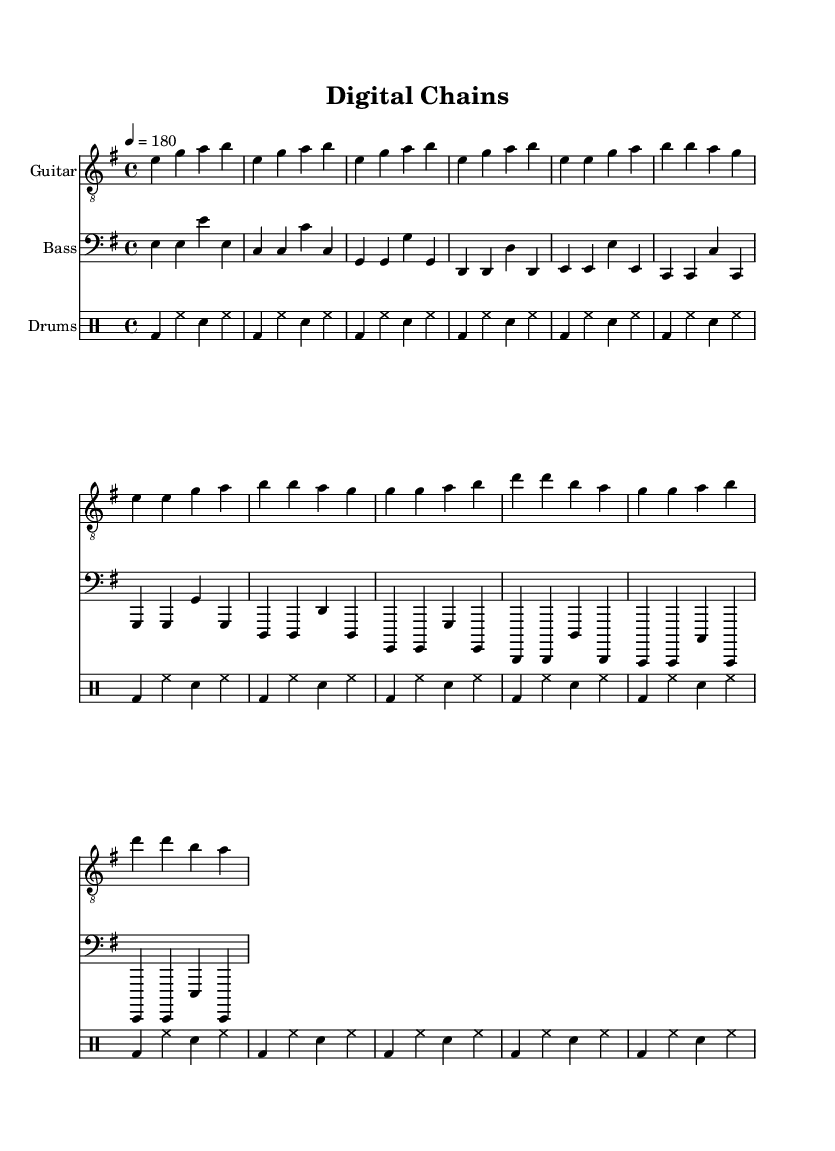What is the key signature of this music? The key signature is indicated by the sharp notes found at the beginning of the piece. In this case, it shows one sharp, which indicates it's in E minor.
Answer: E minor What is the time signature of this piece? The time signature is shown at the beginning of the sheet music, represented as a fraction. Here, it states 4 over 4, indicating four beats in a measure and a quarter note receives one beat.
Answer: 4/4 What is the tempo marking for this music? The tempo marking is indicated at the start with a number and a term. In this case, it shows 4 equals 180, meaning there are 180 beats per minute, reflecting a fast-paced tempo.
Answer: 180 How many measures are in the chorus section? By counting the segments of music notation within the chorus section, we can see there are four distinct measures. Each group of notes separated by vertical lines indicates one measure.
Answer: 4 What lyrical theme does this anthem address? The lyrics express a critical view of social media impact through the metaphor of "digital chains," illustrating a concern over autonomy and the pervasive influence of technology on individual choices. The lyrics' focus on freedom and reclaiming one's voice highlights this theme.
Answer: Social media influence What is the typical structure for punk anthems like this one? Punk anthems often adhere to a basic structure such as verse-chorus-verse. This sheet music showcases that format, with distinct sections for verses and a chorus. This structure facilitates repetition and emphasizes strong lyrical messages typical in punk music.
Answer: Verse-Chorus structure What role do lyrics play in punk music, as demonstrated in this anthem? Lyrics in punk music often serve as a medium for social criticism and personal expression. In this anthem, the lyrics critique digital culture, reflecting punk's tradition of addressing societal issues and fostering a sense of rebellion against conformity.
Answer: Social criticism 